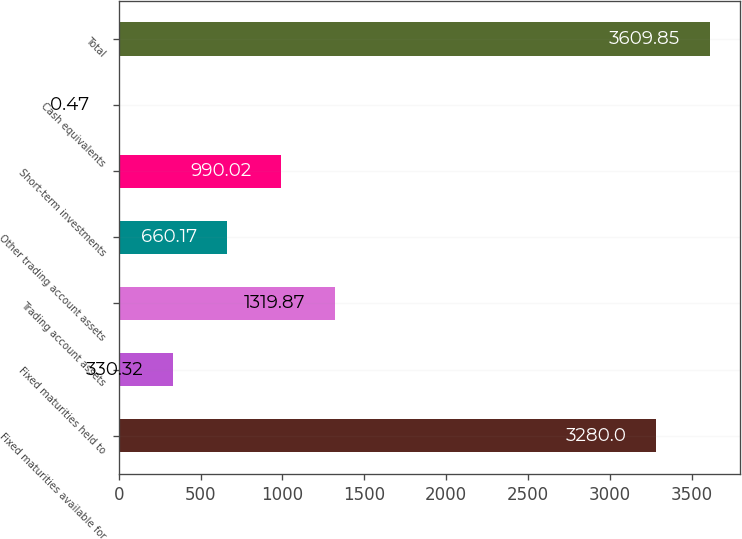<chart> <loc_0><loc_0><loc_500><loc_500><bar_chart><fcel>Fixed maturities available for<fcel>Fixed maturities held to<fcel>Trading account assets<fcel>Other trading account assets<fcel>Short-term investments<fcel>Cash equivalents<fcel>Total<nl><fcel>3280<fcel>330.32<fcel>1319.87<fcel>660.17<fcel>990.02<fcel>0.47<fcel>3609.85<nl></chart> 